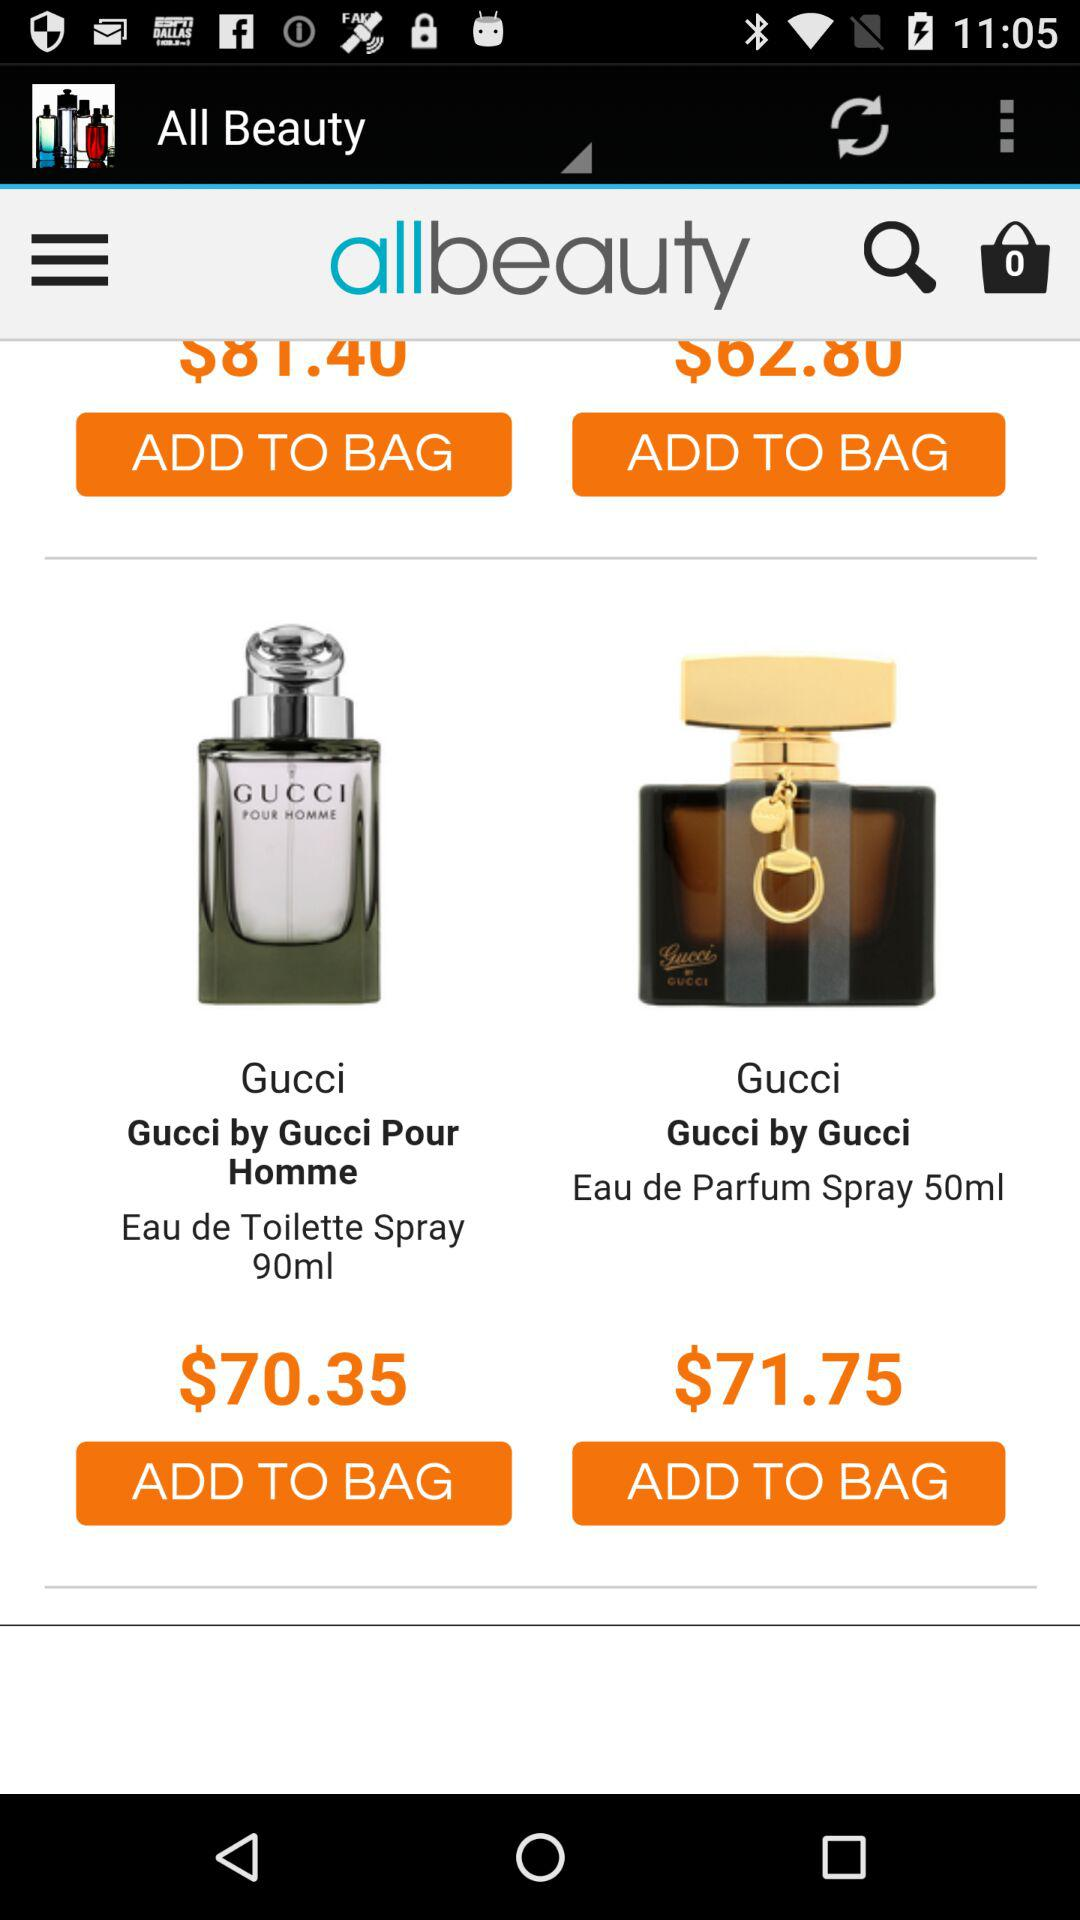How many items are in the bag? There are 0 items in the bag. 